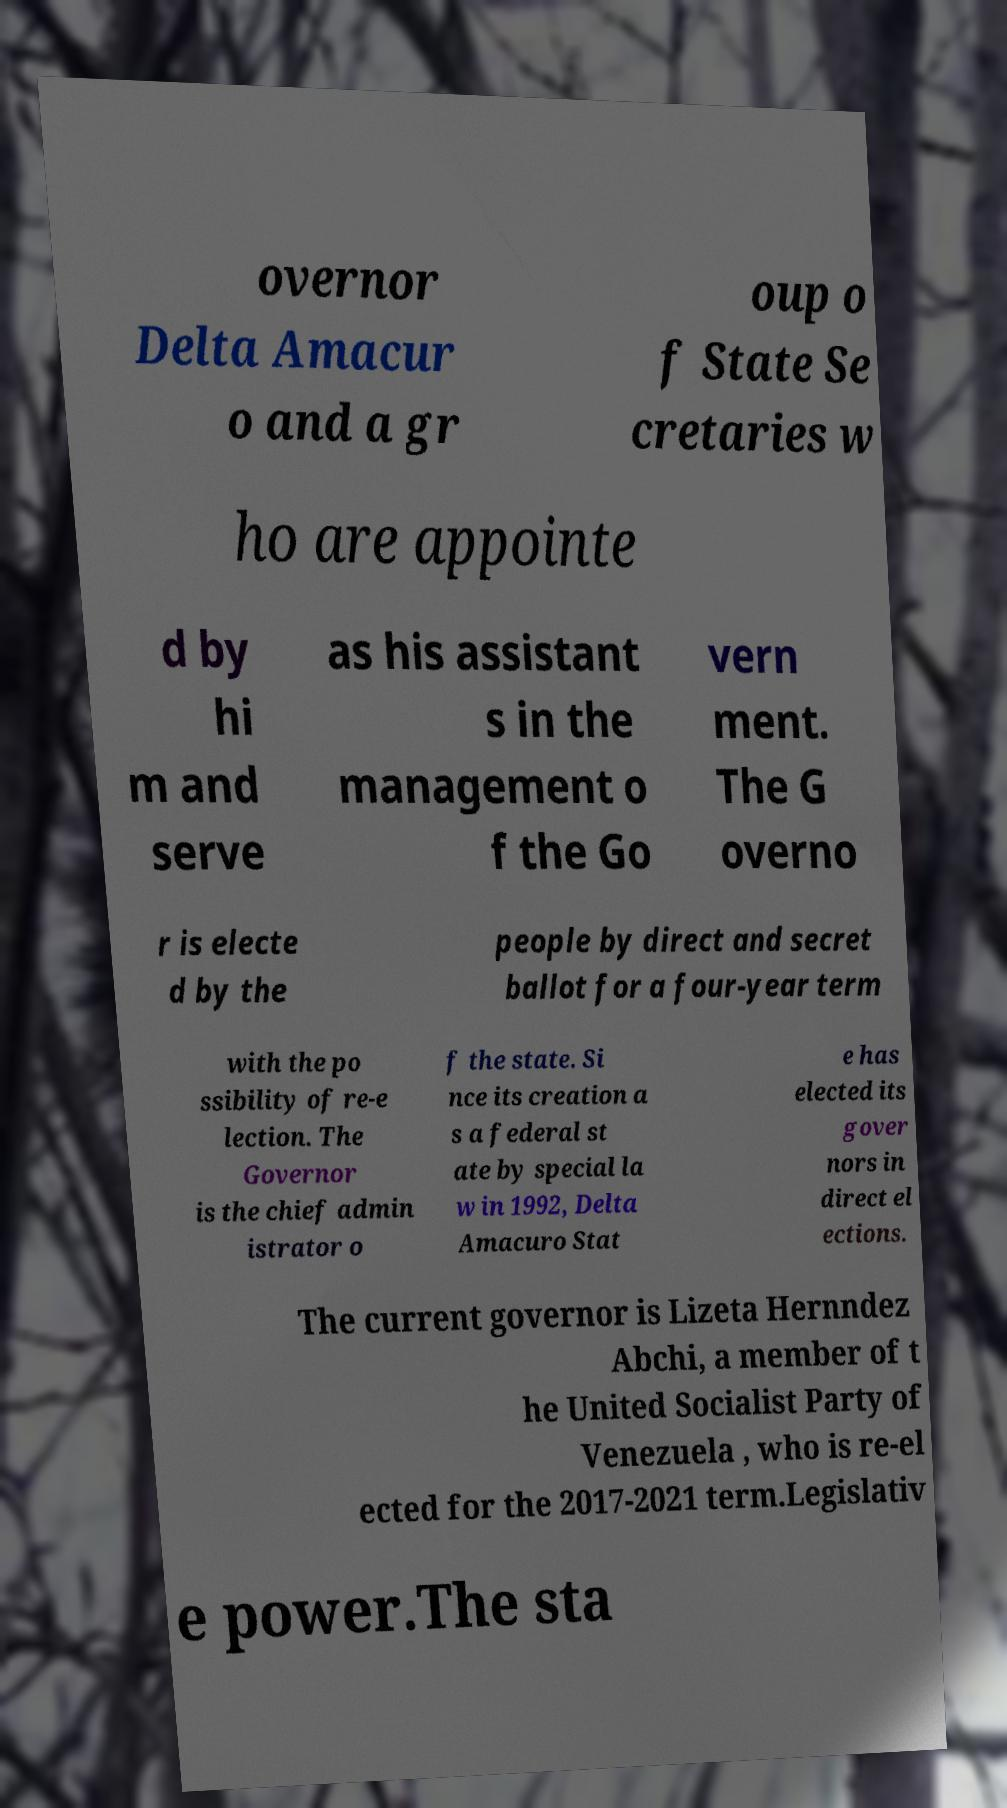What messages or text are displayed in this image? I need them in a readable, typed format. overnor Delta Amacur o and a gr oup o f State Se cretaries w ho are appointe d by hi m and serve as his assistant s in the management o f the Go vern ment. The G overno r is electe d by the people by direct and secret ballot for a four-year term with the po ssibility of re-e lection. The Governor is the chief admin istrator o f the state. Si nce its creation a s a federal st ate by special la w in 1992, Delta Amacuro Stat e has elected its gover nors in direct el ections. The current governor is Lizeta Hernndez Abchi, a member of t he United Socialist Party of Venezuela , who is re-el ected for the 2017-2021 term.Legislativ e power.The sta 